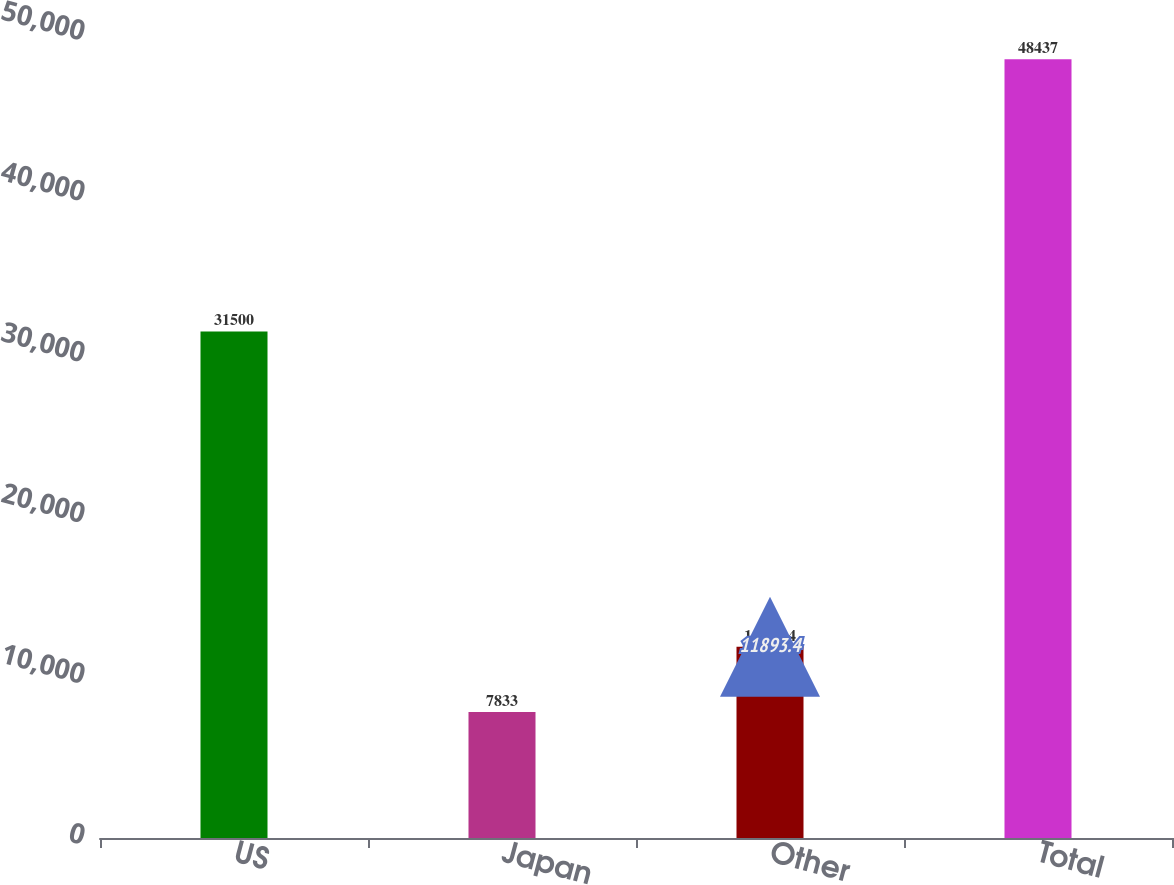<chart> <loc_0><loc_0><loc_500><loc_500><bar_chart><fcel>US<fcel>Japan<fcel>Other<fcel>Total<nl><fcel>31500<fcel>7833<fcel>11893.4<fcel>48437<nl></chart> 